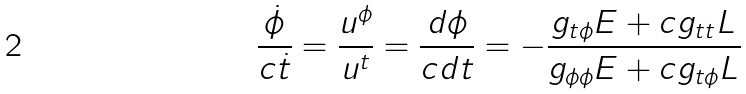<formula> <loc_0><loc_0><loc_500><loc_500>\frac { \dot { \phi } } { c \dot { t } } = \frac { u ^ { \phi } } { u ^ { t } } = \frac { d \phi } { c d t } = - \frac { g _ { t \phi } E + c g _ { t t } L } { g _ { \phi \phi } E + c g _ { t \phi } L }</formula> 